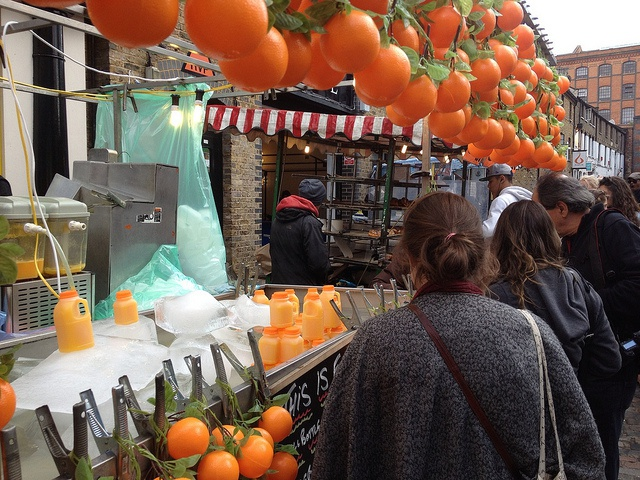Describe the objects in this image and their specific colors. I can see people in darkgray, black, gray, and maroon tones, orange in darkgray, red, brown, and olive tones, people in darkgray, black, maroon, gray, and brown tones, people in darkgray, black, and gray tones, and people in darkgray, black, gray, salmon, and maroon tones in this image. 